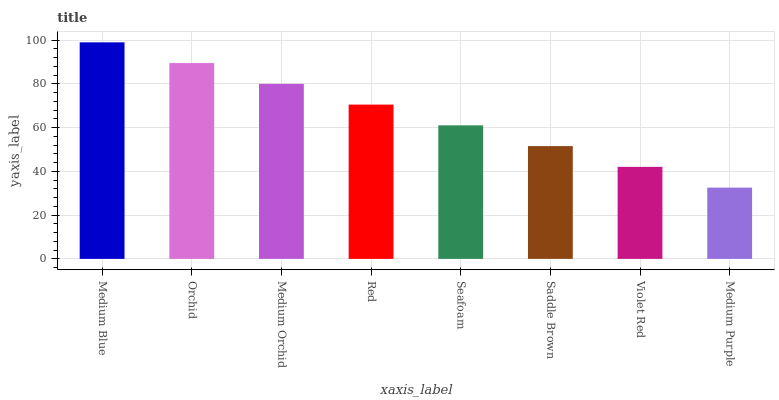Is Medium Purple the minimum?
Answer yes or no. Yes. Is Medium Blue the maximum?
Answer yes or no. Yes. Is Orchid the minimum?
Answer yes or no. No. Is Orchid the maximum?
Answer yes or no. No. Is Medium Blue greater than Orchid?
Answer yes or no. Yes. Is Orchid less than Medium Blue?
Answer yes or no. Yes. Is Orchid greater than Medium Blue?
Answer yes or no. No. Is Medium Blue less than Orchid?
Answer yes or no. No. Is Red the high median?
Answer yes or no. Yes. Is Seafoam the low median?
Answer yes or no. Yes. Is Medium Orchid the high median?
Answer yes or no. No. Is Medium Purple the low median?
Answer yes or no. No. 